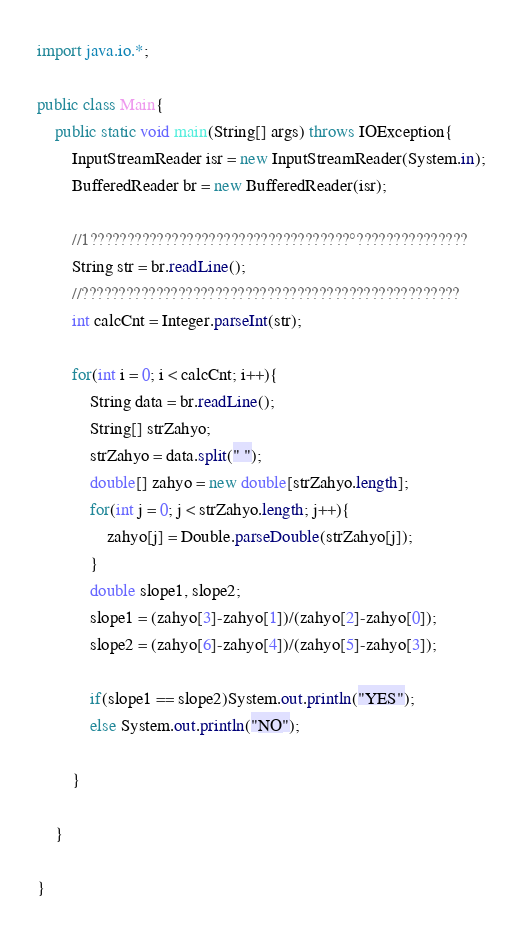Convert code to text. <code><loc_0><loc_0><loc_500><loc_500><_Java_>import java.io.*;

public class Main{
	public static void main(String[] args) throws IOException{
        InputStreamReader isr = new InputStreamReader(System.in);
        BufferedReader br = new BufferedReader(isr);
        
        //1???????????????????????????????????°???????????????
        String str = br.readLine();
        //???????????????????????????????????????????????????
        int calcCnt = Integer.parseInt(str);
        
        for(int i = 0; i < calcCnt; i++){
        	String data = br.readLine();
        	String[] strZahyo;
        	strZahyo = data.split(" ");
        	double[] zahyo = new double[strZahyo.length];
        	for(int j = 0; j < strZahyo.length; j++){
        		zahyo[j] = Double.parseDouble(strZahyo[j]); 
        	}
        	double slope1, slope2;
            slope1 = (zahyo[3]-zahyo[1])/(zahyo[2]-zahyo[0]);
            slope2 = (zahyo[6]-zahyo[4])/(zahyo[5]-zahyo[3]);
            
            if(slope1 == slope2)System.out.println("YES");
            else System.out.println("NO");
            
        }
        
	}

}</code> 